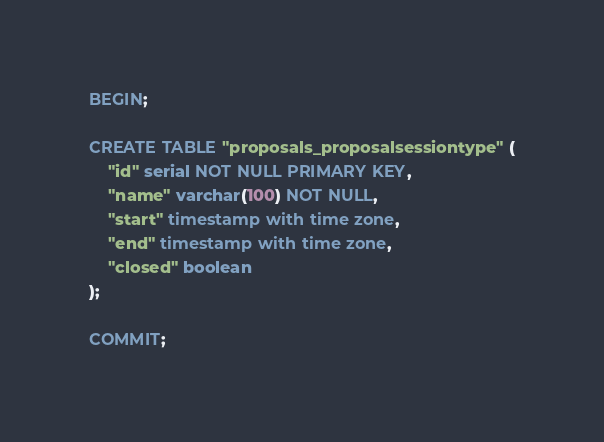Convert code to text. <code><loc_0><loc_0><loc_500><loc_500><_SQL_>BEGIN;

CREATE TABLE "proposals_proposalsessiontype" (
    "id" serial NOT NULL PRIMARY KEY,
    "name" varchar(100) NOT NULL,
    "start" timestamp with time zone,
    "end" timestamp with time zone,
    "closed" boolean
);

COMMIT;</code> 